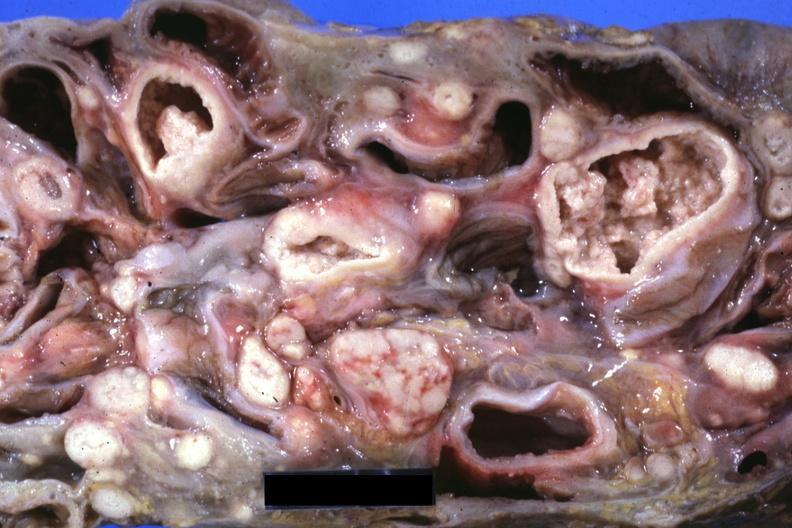what showing lesions that look more like carcinoma but are in fact tuberculosis?
Answer the question using a single word or phrase. Mass of intestines and mesenteric nodes 